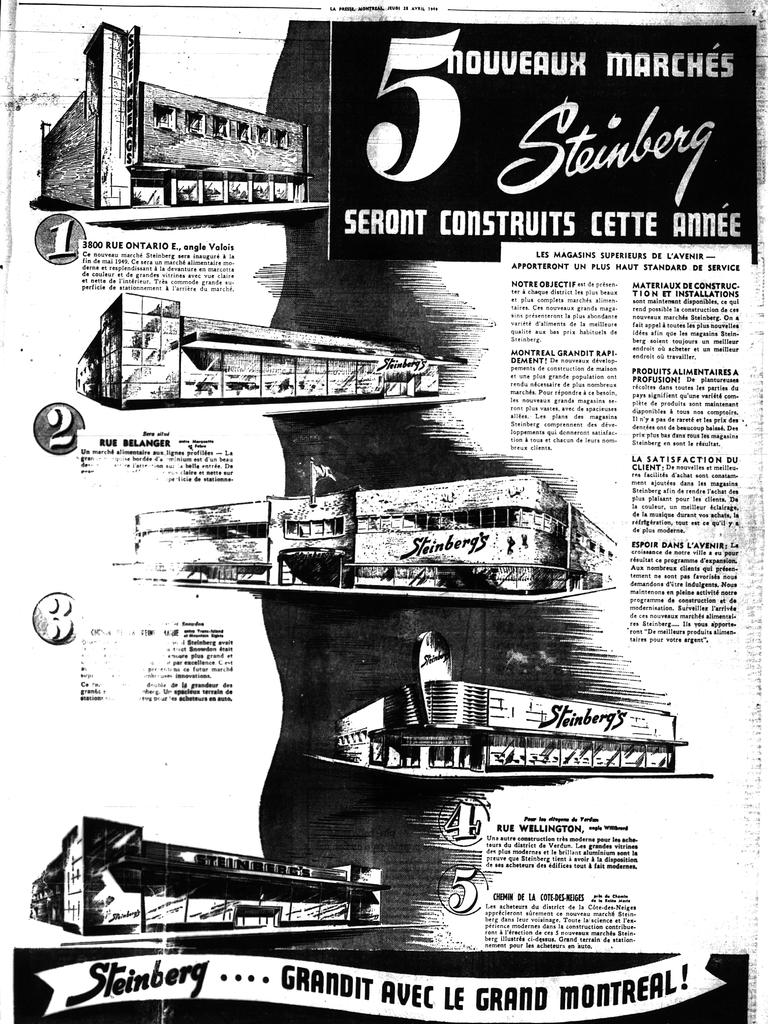<image>
Summarize the visual content of the image. A black and white poster showing 5 items for nouveaux marches. 